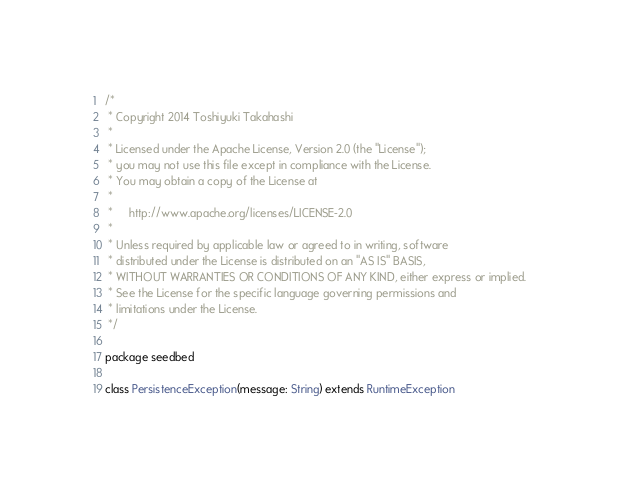Convert code to text. <code><loc_0><loc_0><loc_500><loc_500><_Scala_>/*
 * Copyright 2014 Toshiyuki Takahashi
 *
 * Licensed under the Apache License, Version 2.0 (the "License");
 * you may not use this file except in compliance with the License.
 * You may obtain a copy of the License at
 *
 *     http://www.apache.org/licenses/LICENSE-2.0
 *
 * Unless required by applicable law or agreed to in writing, software
 * distributed under the License is distributed on an "AS IS" BASIS,
 * WITHOUT WARRANTIES OR CONDITIONS OF ANY KIND, either express or implied.
 * See the License for the specific language governing permissions and
 * limitations under the License.
 */

package seedbed

class PersistenceException(message: String) extends RuntimeException
</code> 